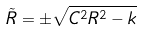<formula> <loc_0><loc_0><loc_500><loc_500>\tilde { R } = \pm \sqrt { C ^ { 2 } R ^ { 2 } - k }</formula> 